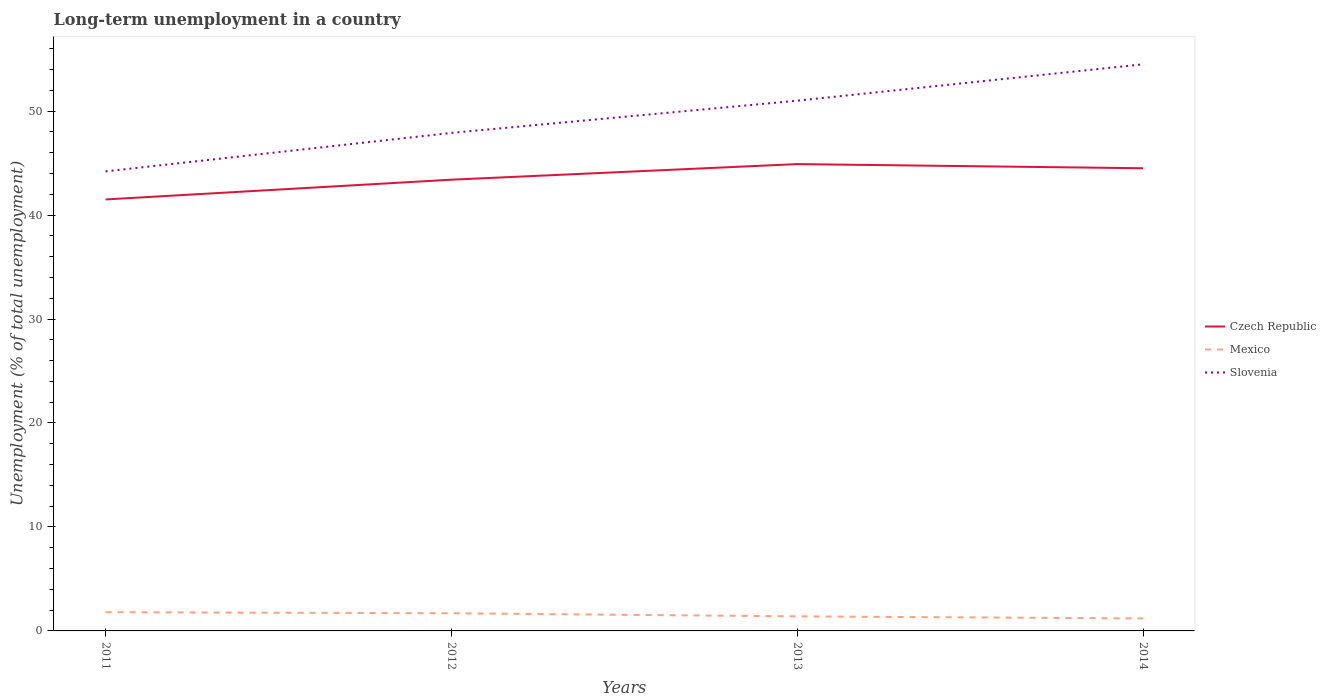How many different coloured lines are there?
Your answer should be very brief. 3. Across all years, what is the maximum percentage of long-term unemployed population in Mexico?
Make the answer very short. 1.2. In which year was the percentage of long-term unemployed population in Mexico maximum?
Your answer should be very brief. 2014. What is the total percentage of long-term unemployed population in Mexico in the graph?
Provide a short and direct response. 0.2. What is the difference between the highest and the second highest percentage of long-term unemployed population in Mexico?
Make the answer very short. 0.6. What is the difference between the highest and the lowest percentage of long-term unemployed population in Mexico?
Your response must be concise. 2. Is the percentage of long-term unemployed population in Mexico strictly greater than the percentage of long-term unemployed population in Slovenia over the years?
Give a very brief answer. Yes. How many years are there in the graph?
Your response must be concise. 4. What is the difference between two consecutive major ticks on the Y-axis?
Your response must be concise. 10. Where does the legend appear in the graph?
Offer a very short reply. Center right. What is the title of the graph?
Provide a succinct answer. Long-term unemployment in a country. What is the label or title of the Y-axis?
Provide a short and direct response. Unemployment (% of total unemployment). What is the Unemployment (% of total unemployment) in Czech Republic in 2011?
Your answer should be very brief. 41.5. What is the Unemployment (% of total unemployment) in Mexico in 2011?
Your answer should be compact. 1.8. What is the Unemployment (% of total unemployment) of Slovenia in 2011?
Make the answer very short. 44.2. What is the Unemployment (% of total unemployment) in Czech Republic in 2012?
Provide a short and direct response. 43.4. What is the Unemployment (% of total unemployment) in Mexico in 2012?
Provide a short and direct response. 1.7. What is the Unemployment (% of total unemployment) of Slovenia in 2012?
Your response must be concise. 47.9. What is the Unemployment (% of total unemployment) in Czech Republic in 2013?
Your response must be concise. 44.9. What is the Unemployment (% of total unemployment) in Mexico in 2013?
Give a very brief answer. 1.4. What is the Unemployment (% of total unemployment) in Czech Republic in 2014?
Offer a very short reply. 44.5. What is the Unemployment (% of total unemployment) in Mexico in 2014?
Ensure brevity in your answer.  1.2. What is the Unemployment (% of total unemployment) in Slovenia in 2014?
Provide a succinct answer. 54.5. Across all years, what is the maximum Unemployment (% of total unemployment) of Czech Republic?
Offer a very short reply. 44.9. Across all years, what is the maximum Unemployment (% of total unemployment) in Mexico?
Provide a short and direct response. 1.8. Across all years, what is the maximum Unemployment (% of total unemployment) of Slovenia?
Provide a succinct answer. 54.5. Across all years, what is the minimum Unemployment (% of total unemployment) in Czech Republic?
Offer a terse response. 41.5. Across all years, what is the minimum Unemployment (% of total unemployment) of Mexico?
Provide a succinct answer. 1.2. Across all years, what is the minimum Unemployment (% of total unemployment) in Slovenia?
Your answer should be compact. 44.2. What is the total Unemployment (% of total unemployment) of Czech Republic in the graph?
Ensure brevity in your answer.  174.3. What is the total Unemployment (% of total unemployment) of Mexico in the graph?
Offer a very short reply. 6.1. What is the total Unemployment (% of total unemployment) of Slovenia in the graph?
Your response must be concise. 197.6. What is the difference between the Unemployment (% of total unemployment) in Czech Republic in 2011 and that in 2012?
Offer a terse response. -1.9. What is the difference between the Unemployment (% of total unemployment) in Czech Republic in 2011 and that in 2013?
Provide a short and direct response. -3.4. What is the difference between the Unemployment (% of total unemployment) of Slovenia in 2011 and that in 2013?
Offer a very short reply. -6.8. What is the difference between the Unemployment (% of total unemployment) in Mexico in 2011 and that in 2014?
Offer a very short reply. 0.6. What is the difference between the Unemployment (% of total unemployment) of Czech Republic in 2012 and that in 2013?
Your response must be concise. -1.5. What is the difference between the Unemployment (% of total unemployment) of Mexico in 2012 and that in 2013?
Your response must be concise. 0.3. What is the difference between the Unemployment (% of total unemployment) in Slovenia in 2012 and that in 2013?
Your answer should be compact. -3.1. What is the difference between the Unemployment (% of total unemployment) of Czech Republic in 2011 and the Unemployment (% of total unemployment) of Mexico in 2012?
Your answer should be very brief. 39.8. What is the difference between the Unemployment (% of total unemployment) of Czech Republic in 2011 and the Unemployment (% of total unemployment) of Slovenia in 2012?
Your answer should be very brief. -6.4. What is the difference between the Unemployment (% of total unemployment) in Mexico in 2011 and the Unemployment (% of total unemployment) in Slovenia in 2012?
Keep it short and to the point. -46.1. What is the difference between the Unemployment (% of total unemployment) of Czech Republic in 2011 and the Unemployment (% of total unemployment) of Mexico in 2013?
Offer a terse response. 40.1. What is the difference between the Unemployment (% of total unemployment) of Mexico in 2011 and the Unemployment (% of total unemployment) of Slovenia in 2013?
Your answer should be compact. -49.2. What is the difference between the Unemployment (% of total unemployment) of Czech Republic in 2011 and the Unemployment (% of total unemployment) of Mexico in 2014?
Ensure brevity in your answer.  40.3. What is the difference between the Unemployment (% of total unemployment) in Mexico in 2011 and the Unemployment (% of total unemployment) in Slovenia in 2014?
Offer a very short reply. -52.7. What is the difference between the Unemployment (% of total unemployment) in Czech Republic in 2012 and the Unemployment (% of total unemployment) in Slovenia in 2013?
Offer a terse response. -7.6. What is the difference between the Unemployment (% of total unemployment) of Mexico in 2012 and the Unemployment (% of total unemployment) of Slovenia in 2013?
Your answer should be very brief. -49.3. What is the difference between the Unemployment (% of total unemployment) in Czech Republic in 2012 and the Unemployment (% of total unemployment) in Mexico in 2014?
Offer a terse response. 42.2. What is the difference between the Unemployment (% of total unemployment) in Czech Republic in 2012 and the Unemployment (% of total unemployment) in Slovenia in 2014?
Keep it short and to the point. -11.1. What is the difference between the Unemployment (% of total unemployment) in Mexico in 2012 and the Unemployment (% of total unemployment) in Slovenia in 2014?
Make the answer very short. -52.8. What is the difference between the Unemployment (% of total unemployment) in Czech Republic in 2013 and the Unemployment (% of total unemployment) in Mexico in 2014?
Your answer should be very brief. 43.7. What is the difference between the Unemployment (% of total unemployment) of Mexico in 2013 and the Unemployment (% of total unemployment) of Slovenia in 2014?
Give a very brief answer. -53.1. What is the average Unemployment (% of total unemployment) in Czech Republic per year?
Your answer should be very brief. 43.58. What is the average Unemployment (% of total unemployment) of Mexico per year?
Provide a succinct answer. 1.52. What is the average Unemployment (% of total unemployment) of Slovenia per year?
Make the answer very short. 49.4. In the year 2011, what is the difference between the Unemployment (% of total unemployment) of Czech Republic and Unemployment (% of total unemployment) of Mexico?
Your answer should be very brief. 39.7. In the year 2011, what is the difference between the Unemployment (% of total unemployment) of Czech Republic and Unemployment (% of total unemployment) of Slovenia?
Provide a succinct answer. -2.7. In the year 2011, what is the difference between the Unemployment (% of total unemployment) in Mexico and Unemployment (% of total unemployment) in Slovenia?
Provide a succinct answer. -42.4. In the year 2012, what is the difference between the Unemployment (% of total unemployment) in Czech Republic and Unemployment (% of total unemployment) in Mexico?
Provide a succinct answer. 41.7. In the year 2012, what is the difference between the Unemployment (% of total unemployment) of Czech Republic and Unemployment (% of total unemployment) of Slovenia?
Your answer should be very brief. -4.5. In the year 2012, what is the difference between the Unemployment (% of total unemployment) of Mexico and Unemployment (% of total unemployment) of Slovenia?
Your answer should be very brief. -46.2. In the year 2013, what is the difference between the Unemployment (% of total unemployment) in Czech Republic and Unemployment (% of total unemployment) in Mexico?
Offer a terse response. 43.5. In the year 2013, what is the difference between the Unemployment (% of total unemployment) of Czech Republic and Unemployment (% of total unemployment) of Slovenia?
Provide a succinct answer. -6.1. In the year 2013, what is the difference between the Unemployment (% of total unemployment) in Mexico and Unemployment (% of total unemployment) in Slovenia?
Give a very brief answer. -49.6. In the year 2014, what is the difference between the Unemployment (% of total unemployment) of Czech Republic and Unemployment (% of total unemployment) of Mexico?
Give a very brief answer. 43.3. In the year 2014, what is the difference between the Unemployment (% of total unemployment) in Mexico and Unemployment (% of total unemployment) in Slovenia?
Offer a very short reply. -53.3. What is the ratio of the Unemployment (% of total unemployment) in Czech Republic in 2011 to that in 2012?
Your answer should be compact. 0.96. What is the ratio of the Unemployment (% of total unemployment) in Mexico in 2011 to that in 2012?
Your answer should be very brief. 1.06. What is the ratio of the Unemployment (% of total unemployment) in Slovenia in 2011 to that in 2012?
Offer a terse response. 0.92. What is the ratio of the Unemployment (% of total unemployment) of Czech Republic in 2011 to that in 2013?
Make the answer very short. 0.92. What is the ratio of the Unemployment (% of total unemployment) of Mexico in 2011 to that in 2013?
Your answer should be compact. 1.29. What is the ratio of the Unemployment (% of total unemployment) in Slovenia in 2011 to that in 2013?
Your response must be concise. 0.87. What is the ratio of the Unemployment (% of total unemployment) in Czech Republic in 2011 to that in 2014?
Make the answer very short. 0.93. What is the ratio of the Unemployment (% of total unemployment) of Mexico in 2011 to that in 2014?
Make the answer very short. 1.5. What is the ratio of the Unemployment (% of total unemployment) in Slovenia in 2011 to that in 2014?
Keep it short and to the point. 0.81. What is the ratio of the Unemployment (% of total unemployment) in Czech Republic in 2012 to that in 2013?
Keep it short and to the point. 0.97. What is the ratio of the Unemployment (% of total unemployment) in Mexico in 2012 to that in 2013?
Make the answer very short. 1.21. What is the ratio of the Unemployment (% of total unemployment) of Slovenia in 2012 to that in 2013?
Give a very brief answer. 0.94. What is the ratio of the Unemployment (% of total unemployment) in Czech Republic in 2012 to that in 2014?
Your answer should be compact. 0.98. What is the ratio of the Unemployment (% of total unemployment) of Mexico in 2012 to that in 2014?
Offer a very short reply. 1.42. What is the ratio of the Unemployment (% of total unemployment) in Slovenia in 2012 to that in 2014?
Provide a succinct answer. 0.88. What is the ratio of the Unemployment (% of total unemployment) of Czech Republic in 2013 to that in 2014?
Provide a succinct answer. 1.01. What is the ratio of the Unemployment (% of total unemployment) in Mexico in 2013 to that in 2014?
Ensure brevity in your answer.  1.17. What is the ratio of the Unemployment (% of total unemployment) in Slovenia in 2013 to that in 2014?
Offer a terse response. 0.94. What is the difference between the highest and the second highest Unemployment (% of total unemployment) in Mexico?
Provide a succinct answer. 0.1. What is the difference between the highest and the second highest Unemployment (% of total unemployment) of Slovenia?
Give a very brief answer. 3.5. What is the difference between the highest and the lowest Unemployment (% of total unemployment) of Czech Republic?
Keep it short and to the point. 3.4. What is the difference between the highest and the lowest Unemployment (% of total unemployment) in Mexico?
Your answer should be compact. 0.6. What is the difference between the highest and the lowest Unemployment (% of total unemployment) in Slovenia?
Your answer should be compact. 10.3. 